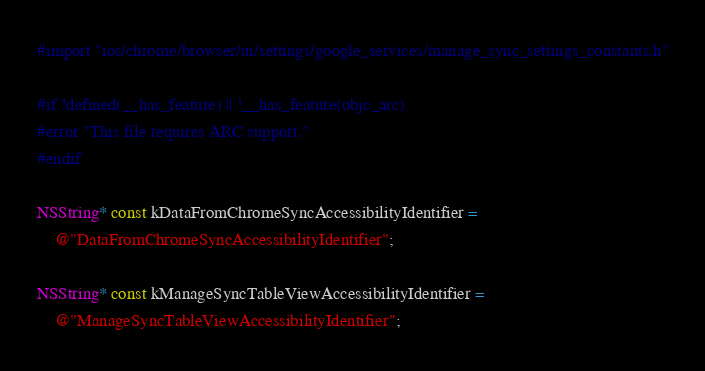<code> <loc_0><loc_0><loc_500><loc_500><_ObjectiveC_>#import "ios/chrome/browser/ui/settings/google_services/manage_sync_settings_constants.h"

#if !defined(__has_feature) || !__has_feature(objc_arc)
#error "This file requires ARC support."
#endif

NSString* const kDataFromChromeSyncAccessibilityIdentifier =
    @"DataFromChromeSyncAccessibilityIdentifier";

NSString* const kManageSyncTableViewAccessibilityIdentifier =
    @"ManageSyncTableViewAccessibilityIdentifier";
</code> 